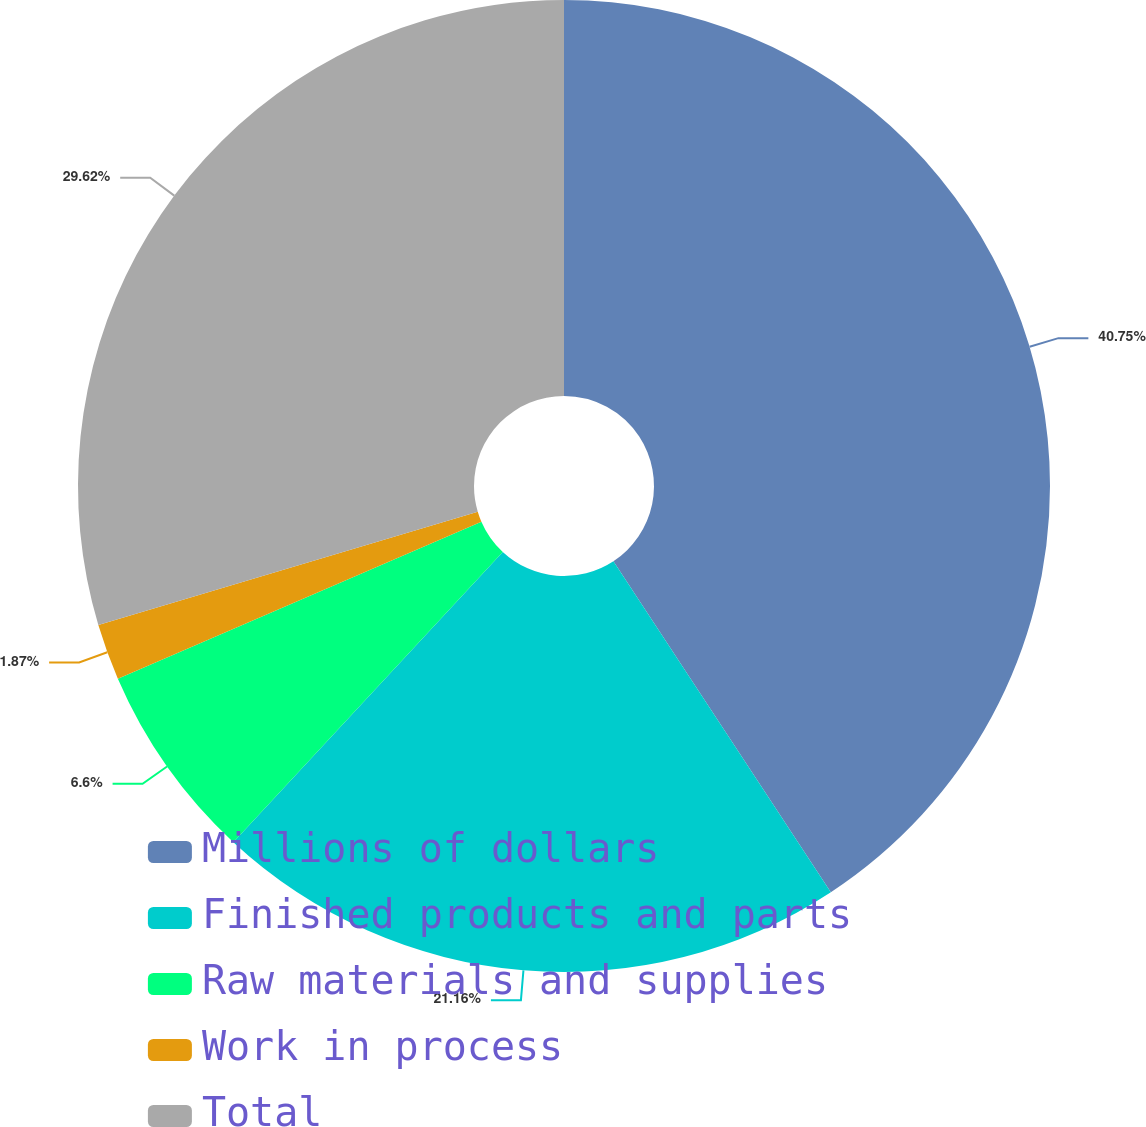Convert chart to OTSL. <chart><loc_0><loc_0><loc_500><loc_500><pie_chart><fcel>Millions of dollars<fcel>Finished products and parts<fcel>Raw materials and supplies<fcel>Work in process<fcel>Total<nl><fcel>40.75%<fcel>21.16%<fcel>6.6%<fcel>1.87%<fcel>29.62%<nl></chart> 